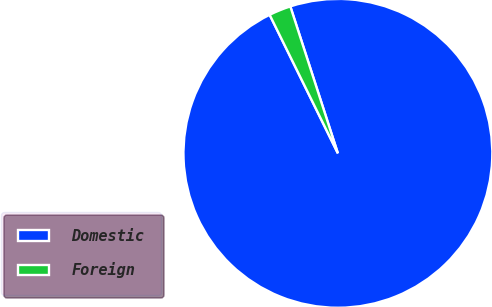Convert chart. <chart><loc_0><loc_0><loc_500><loc_500><pie_chart><fcel>Domestic<fcel>Foreign<nl><fcel>97.7%<fcel>2.3%<nl></chart> 